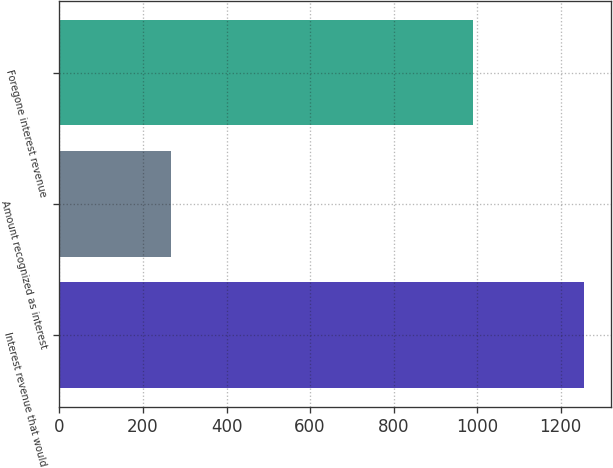Convert chart. <chart><loc_0><loc_0><loc_500><loc_500><bar_chart><fcel>Interest revenue that would<fcel>Amount recognized as interest<fcel>Foregone interest revenue<nl><fcel>1257<fcel>267<fcel>990<nl></chart> 